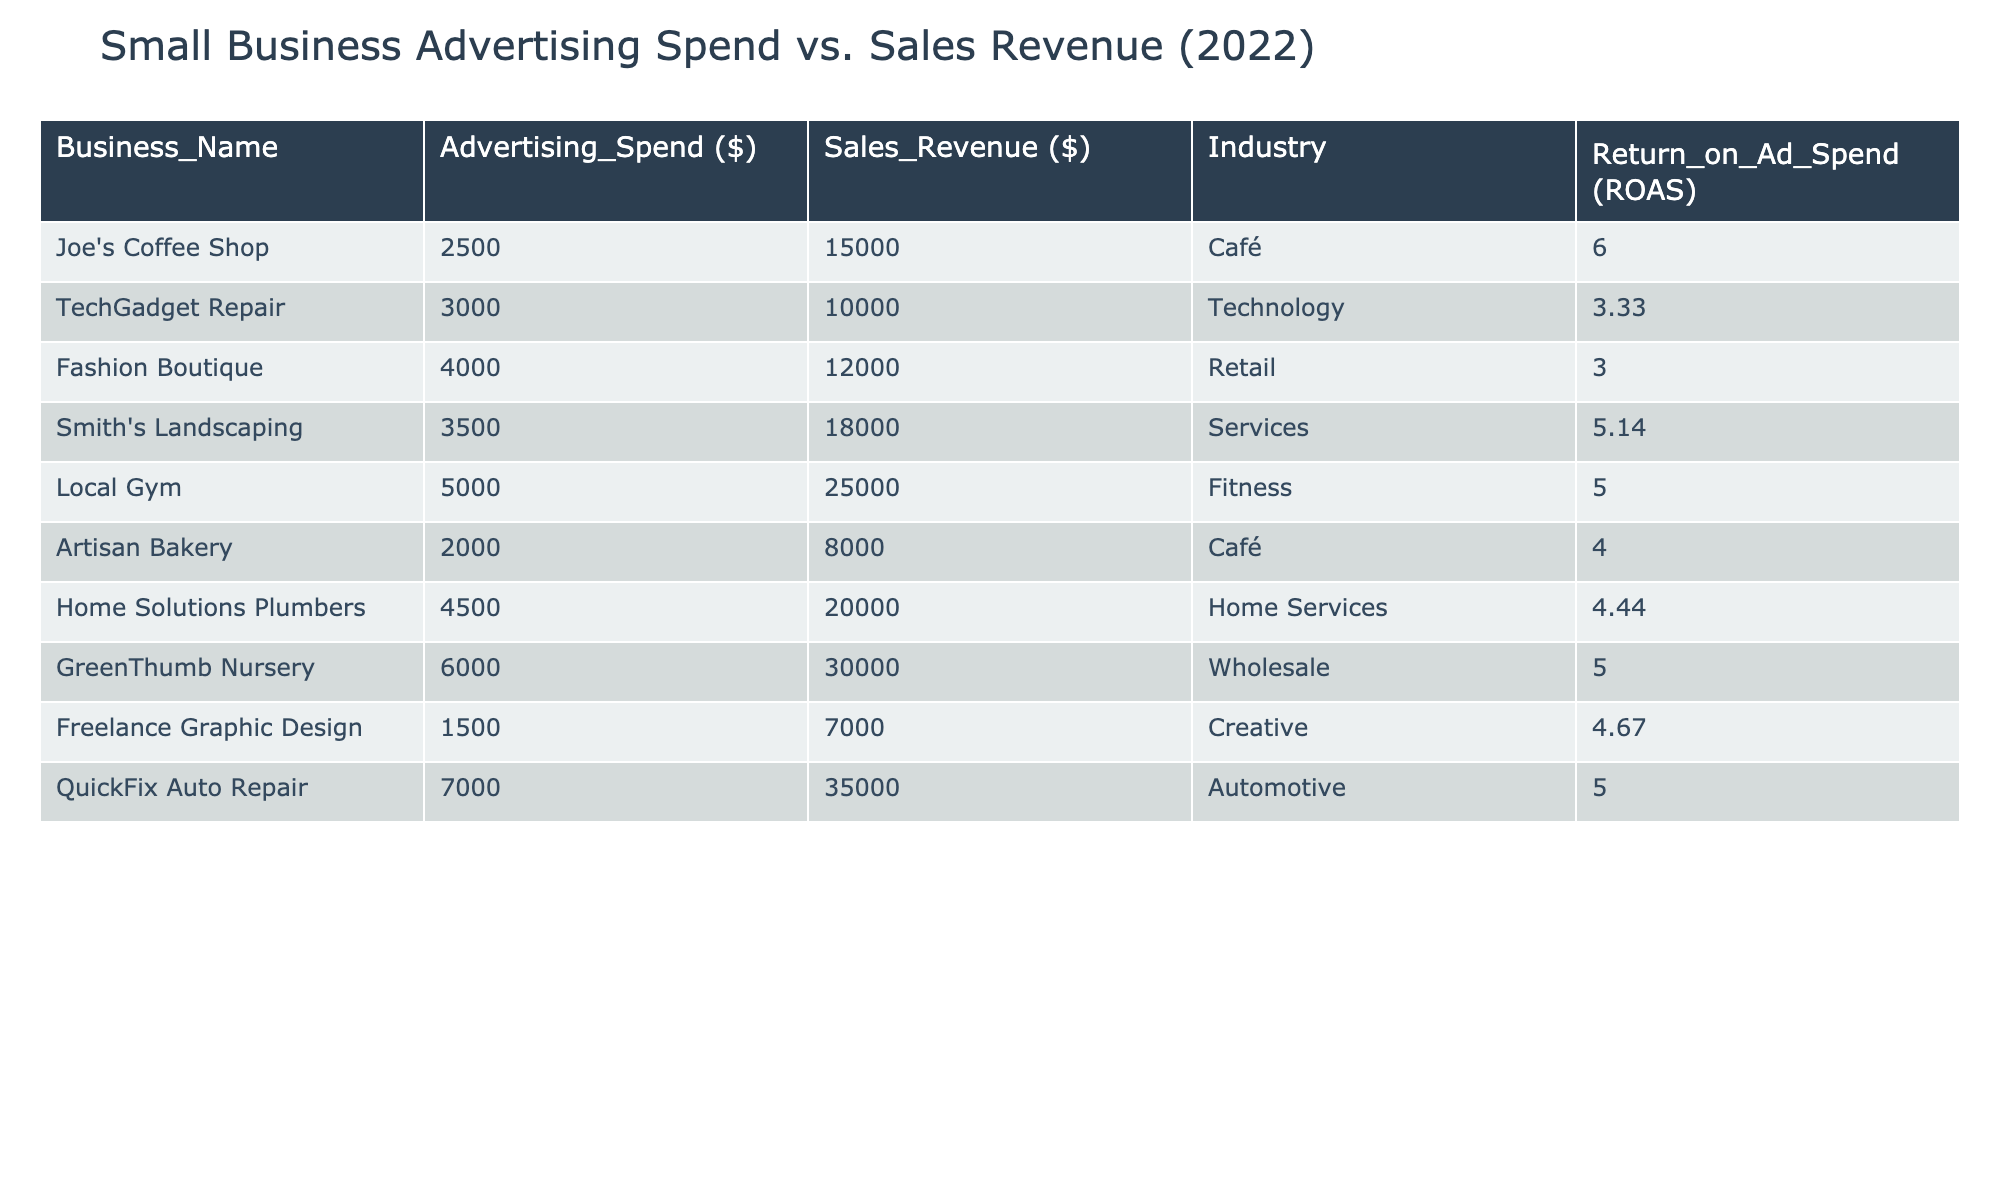What is the highest advertising spend recorded in the table? The table lists the advertising spend for each business. By quickly scanning the "Advertising_Spend ($)" column, we can see that QuickFix Auto Repair has the highest spend of 7000 dollars.
Answer: 7000 Which business achieved the highest return on ad spend (ROAS)? To find the highest ROAS, look at the "Return_on_Ad_Spend (ROAS)" column. Joe's Coffee Shop shows a ROAS of 6.0, which is the highest among all the entries listed.
Answer: Joe's Coffee Shop What is the total sales revenue generated by businesses in the café industry? For the café industry, we have Joe's Coffee Shop (15000) and Artisan Bakery (8000). Adding these together gives 15000 + 8000 = 23000. Therefore, the total sales revenue for the café industry is 23000 dollars.
Answer: 23000 Is there any business that spent less than 3000 dollars on advertising? By examining the "Advertising_Spend ($)" column, we find that both Joe's Coffee Shop (2500) and Freelance Graphic Design (1500) spent less than 3000 dollars. Therefore, the answer is yes.
Answer: Yes What is the average sales revenue of the businesses listed in the table? First, we sum all sales revenues: 15000 + 10000 + 12000 + 18000 + 25000 + 8000 + 20000 + 30000 + 7000 + 35000 = 127000. There are 10 entries, so we divide by 10 to find the average: 127000 / 10 = 12700.
Answer: 12700 Which industry had the lowest return on ad spend? We must examine the "Return_on_Ad_Spend (ROAS)" values for each industry. Fashion Boutique shows the lowest ROAS at 3.0, making it the industry with the lowest return on ad spend.
Answer: Retail How much more sales revenue does Local Gym generate compared to Artisan Bakery? Local Gym's sales revenue is 25000 and Artisan Bakery's is 8000. To find the difference, we subtract 8000 from 25000, which gives 25000 - 8000 = 17000. Therefore, Local Gym generates 17000 more dollars in sales revenue than Artisan Bakery.
Answer: 17000 Is the average advertising spend greater than 4000 dollars? The total advertising spend is 2500 + 3000 + 4000 + 3500 + 5000 + 2000 + 4500 + 6000 + 1500 + 7000 = 30000. Dividing this total by the number of businesses (10) yields an average of 30000 / 10 = 3000. Thus, the average advertising spend is not greater than 4000 dollars.
Answer: No What can be inferred about the relationship between advertising spend and sales revenue for the businesses listed? The table suggests a positive relationship between advertising spend and sales revenue. Generally, as advertising spend increases, sales revenue tends to be higher, as seen with QuickFix Auto Repair and Local Gym, both showing substantial sales revenues with higher ad spends. Further analysis could provide more insights into the strength of this correlation.
Answer: Generally positive correlation 